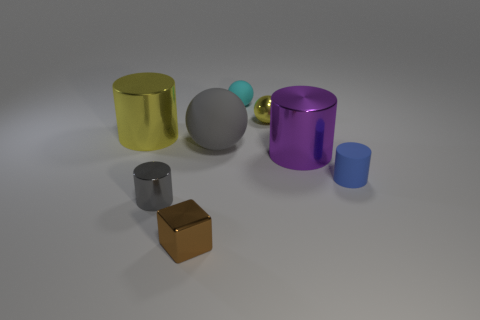Subtract 1 cylinders. How many cylinders are left? 3 Add 2 blue matte objects. How many objects exist? 10 Subtract all blocks. How many objects are left? 7 Add 8 rubber cylinders. How many rubber cylinders are left? 9 Add 2 blue matte blocks. How many blue matte blocks exist? 2 Subtract 0 purple spheres. How many objects are left? 8 Subtract all large blue shiny cubes. Subtract all small cyan things. How many objects are left? 7 